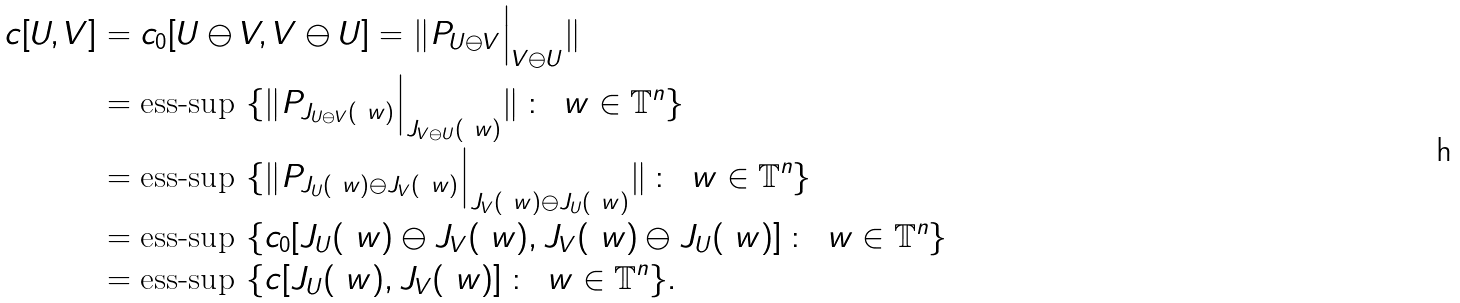Convert formula to latex. <formula><loc_0><loc_0><loc_500><loc_500>c [ U , V ] & = c _ { 0 } [ U \ominus V , V \ominus U ] = \| P _ { U \ominus V } \Big | _ { V \ominus U } \| \\ & = \text {ess-sup } \{ \| P _ { J _ { U \ominus V } ( \ w ) } \Big | _ { J _ { V \ominus U } ( \ w ) } \| \, \colon \, \ w \in \mathbb { T } ^ { n } \} \\ & = \text {ess-sup } \{ \| P _ { J _ { U } ( \ w ) \ominus J _ { V } ( \ w ) } \Big | _ { J _ { V } ( \ w ) \ominus J _ { U } ( \ w ) } \| \, \colon \, \ w \in \mathbb { T } ^ { n } \} \\ & = \text {ess-sup } \{ c _ { 0 } [ J _ { U } ( \ w ) \ominus J _ { V } ( \ w ) , J _ { V } ( \ w ) \ominus J _ { U } ( \ w ) ] \, \colon \, \ w \in \mathbb { T } ^ { n } \} \\ & = \text {ess-sup } \{ c [ J _ { U } ( \ w ) , J _ { V } ( \ w ) ] \, \colon \, \ w \in \mathbb { T } ^ { n } \} .</formula> 